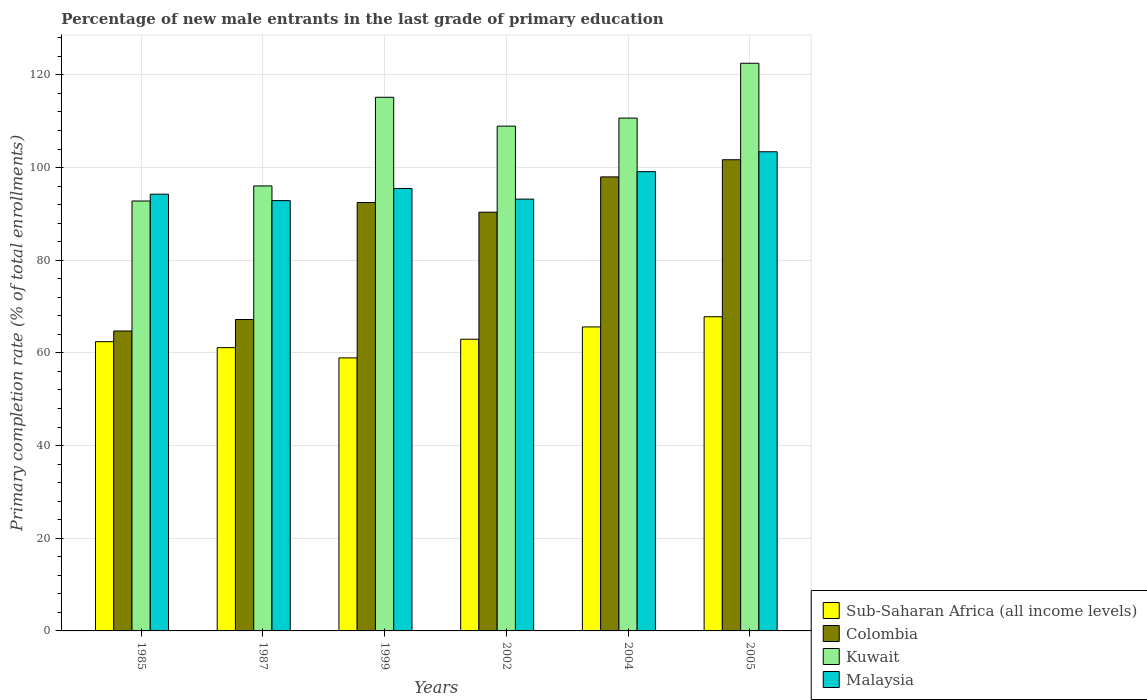Are the number of bars per tick equal to the number of legend labels?
Make the answer very short. Yes. How many bars are there on the 3rd tick from the left?
Give a very brief answer. 4. How many bars are there on the 1st tick from the right?
Keep it short and to the point. 4. What is the percentage of new male entrants in Malaysia in 1999?
Your answer should be very brief. 95.49. Across all years, what is the maximum percentage of new male entrants in Kuwait?
Offer a terse response. 122.51. Across all years, what is the minimum percentage of new male entrants in Colombia?
Make the answer very short. 64.73. In which year was the percentage of new male entrants in Sub-Saharan Africa (all income levels) maximum?
Your answer should be compact. 2005. In which year was the percentage of new male entrants in Colombia minimum?
Your answer should be very brief. 1985. What is the total percentage of new male entrants in Colombia in the graph?
Offer a terse response. 514.42. What is the difference between the percentage of new male entrants in Sub-Saharan Africa (all income levels) in 1985 and that in 2004?
Provide a succinct answer. -3.19. What is the difference between the percentage of new male entrants in Kuwait in 2002 and the percentage of new male entrants in Sub-Saharan Africa (all income levels) in 1985?
Offer a terse response. 46.52. What is the average percentage of new male entrants in Colombia per year?
Offer a terse response. 85.74. In the year 1999, what is the difference between the percentage of new male entrants in Colombia and percentage of new male entrants in Malaysia?
Provide a succinct answer. -3.03. What is the ratio of the percentage of new male entrants in Sub-Saharan Africa (all income levels) in 2002 to that in 2004?
Make the answer very short. 0.96. Is the percentage of new male entrants in Kuwait in 1987 less than that in 2002?
Keep it short and to the point. Yes. Is the difference between the percentage of new male entrants in Colombia in 1987 and 2002 greater than the difference between the percentage of new male entrants in Malaysia in 1987 and 2002?
Ensure brevity in your answer.  No. What is the difference between the highest and the second highest percentage of new male entrants in Kuwait?
Offer a terse response. 7.34. What is the difference between the highest and the lowest percentage of new male entrants in Malaysia?
Offer a terse response. 10.55. Is it the case that in every year, the sum of the percentage of new male entrants in Colombia and percentage of new male entrants in Malaysia is greater than the sum of percentage of new male entrants in Kuwait and percentage of new male entrants in Sub-Saharan Africa (all income levels)?
Keep it short and to the point. No. What does the 4th bar from the left in 2004 represents?
Provide a succinct answer. Malaysia. What does the 4th bar from the right in 2005 represents?
Your answer should be compact. Sub-Saharan Africa (all income levels). Are all the bars in the graph horizontal?
Ensure brevity in your answer.  No. How many years are there in the graph?
Your answer should be compact. 6. What is the difference between two consecutive major ticks on the Y-axis?
Make the answer very short. 20. Are the values on the major ticks of Y-axis written in scientific E-notation?
Your answer should be compact. No. Does the graph contain any zero values?
Provide a succinct answer. No. What is the title of the graph?
Your answer should be very brief. Percentage of new male entrants in the last grade of primary education. Does "San Marino" appear as one of the legend labels in the graph?
Offer a very short reply. No. What is the label or title of the X-axis?
Provide a short and direct response. Years. What is the label or title of the Y-axis?
Provide a short and direct response. Primary completion rate (% of total enrollments). What is the Primary completion rate (% of total enrollments) in Sub-Saharan Africa (all income levels) in 1985?
Provide a short and direct response. 62.42. What is the Primary completion rate (% of total enrollments) in Colombia in 1985?
Provide a succinct answer. 64.73. What is the Primary completion rate (% of total enrollments) in Kuwait in 1985?
Your response must be concise. 92.78. What is the Primary completion rate (% of total enrollments) of Malaysia in 1985?
Ensure brevity in your answer.  94.25. What is the Primary completion rate (% of total enrollments) of Sub-Saharan Africa (all income levels) in 1987?
Your response must be concise. 61.14. What is the Primary completion rate (% of total enrollments) in Colombia in 1987?
Your response must be concise. 67.21. What is the Primary completion rate (% of total enrollments) in Kuwait in 1987?
Make the answer very short. 96.04. What is the Primary completion rate (% of total enrollments) of Malaysia in 1987?
Keep it short and to the point. 92.86. What is the Primary completion rate (% of total enrollments) in Sub-Saharan Africa (all income levels) in 1999?
Your response must be concise. 58.92. What is the Primary completion rate (% of total enrollments) in Colombia in 1999?
Provide a short and direct response. 92.46. What is the Primary completion rate (% of total enrollments) of Kuwait in 1999?
Your answer should be very brief. 115.16. What is the Primary completion rate (% of total enrollments) in Malaysia in 1999?
Your answer should be compact. 95.49. What is the Primary completion rate (% of total enrollments) of Sub-Saharan Africa (all income levels) in 2002?
Give a very brief answer. 62.95. What is the Primary completion rate (% of total enrollments) of Colombia in 2002?
Offer a very short reply. 90.36. What is the Primary completion rate (% of total enrollments) in Kuwait in 2002?
Give a very brief answer. 108.94. What is the Primary completion rate (% of total enrollments) of Malaysia in 2002?
Your answer should be very brief. 93.19. What is the Primary completion rate (% of total enrollments) of Sub-Saharan Africa (all income levels) in 2004?
Your answer should be compact. 65.61. What is the Primary completion rate (% of total enrollments) of Colombia in 2004?
Provide a short and direct response. 97.98. What is the Primary completion rate (% of total enrollments) of Kuwait in 2004?
Ensure brevity in your answer.  110.67. What is the Primary completion rate (% of total enrollments) in Malaysia in 2004?
Your answer should be compact. 99.11. What is the Primary completion rate (% of total enrollments) in Sub-Saharan Africa (all income levels) in 2005?
Provide a short and direct response. 67.8. What is the Primary completion rate (% of total enrollments) of Colombia in 2005?
Give a very brief answer. 101.69. What is the Primary completion rate (% of total enrollments) of Kuwait in 2005?
Keep it short and to the point. 122.51. What is the Primary completion rate (% of total enrollments) in Malaysia in 2005?
Your answer should be very brief. 103.41. Across all years, what is the maximum Primary completion rate (% of total enrollments) in Sub-Saharan Africa (all income levels)?
Give a very brief answer. 67.8. Across all years, what is the maximum Primary completion rate (% of total enrollments) of Colombia?
Provide a succinct answer. 101.69. Across all years, what is the maximum Primary completion rate (% of total enrollments) in Kuwait?
Provide a short and direct response. 122.51. Across all years, what is the maximum Primary completion rate (% of total enrollments) of Malaysia?
Provide a succinct answer. 103.41. Across all years, what is the minimum Primary completion rate (% of total enrollments) of Sub-Saharan Africa (all income levels)?
Offer a very short reply. 58.92. Across all years, what is the minimum Primary completion rate (% of total enrollments) in Colombia?
Offer a very short reply. 64.73. Across all years, what is the minimum Primary completion rate (% of total enrollments) in Kuwait?
Your response must be concise. 92.78. Across all years, what is the minimum Primary completion rate (% of total enrollments) of Malaysia?
Provide a short and direct response. 92.86. What is the total Primary completion rate (% of total enrollments) of Sub-Saharan Africa (all income levels) in the graph?
Offer a very short reply. 378.83. What is the total Primary completion rate (% of total enrollments) in Colombia in the graph?
Make the answer very short. 514.42. What is the total Primary completion rate (% of total enrollments) of Kuwait in the graph?
Your answer should be compact. 646.1. What is the total Primary completion rate (% of total enrollments) of Malaysia in the graph?
Your response must be concise. 578.3. What is the difference between the Primary completion rate (% of total enrollments) of Sub-Saharan Africa (all income levels) in 1985 and that in 1987?
Make the answer very short. 1.28. What is the difference between the Primary completion rate (% of total enrollments) in Colombia in 1985 and that in 1987?
Your answer should be compact. -2.48. What is the difference between the Primary completion rate (% of total enrollments) of Kuwait in 1985 and that in 1987?
Your answer should be very brief. -3.26. What is the difference between the Primary completion rate (% of total enrollments) of Malaysia in 1985 and that in 1987?
Keep it short and to the point. 1.39. What is the difference between the Primary completion rate (% of total enrollments) in Sub-Saharan Africa (all income levels) in 1985 and that in 1999?
Offer a terse response. 3.5. What is the difference between the Primary completion rate (% of total enrollments) in Colombia in 1985 and that in 1999?
Provide a short and direct response. -27.73. What is the difference between the Primary completion rate (% of total enrollments) in Kuwait in 1985 and that in 1999?
Provide a short and direct response. -22.38. What is the difference between the Primary completion rate (% of total enrollments) of Malaysia in 1985 and that in 1999?
Ensure brevity in your answer.  -1.24. What is the difference between the Primary completion rate (% of total enrollments) of Sub-Saharan Africa (all income levels) in 1985 and that in 2002?
Offer a terse response. -0.53. What is the difference between the Primary completion rate (% of total enrollments) of Colombia in 1985 and that in 2002?
Your response must be concise. -25.63. What is the difference between the Primary completion rate (% of total enrollments) of Kuwait in 1985 and that in 2002?
Ensure brevity in your answer.  -16.16. What is the difference between the Primary completion rate (% of total enrollments) in Malaysia in 1985 and that in 2002?
Offer a very short reply. 1.06. What is the difference between the Primary completion rate (% of total enrollments) of Sub-Saharan Africa (all income levels) in 1985 and that in 2004?
Your response must be concise. -3.19. What is the difference between the Primary completion rate (% of total enrollments) in Colombia in 1985 and that in 2004?
Your response must be concise. -33.25. What is the difference between the Primary completion rate (% of total enrollments) of Kuwait in 1985 and that in 2004?
Provide a succinct answer. -17.89. What is the difference between the Primary completion rate (% of total enrollments) of Malaysia in 1985 and that in 2004?
Offer a terse response. -4.87. What is the difference between the Primary completion rate (% of total enrollments) in Sub-Saharan Africa (all income levels) in 1985 and that in 2005?
Your response must be concise. -5.38. What is the difference between the Primary completion rate (% of total enrollments) in Colombia in 1985 and that in 2005?
Offer a very short reply. -36.96. What is the difference between the Primary completion rate (% of total enrollments) of Kuwait in 1985 and that in 2005?
Give a very brief answer. -29.73. What is the difference between the Primary completion rate (% of total enrollments) of Malaysia in 1985 and that in 2005?
Give a very brief answer. -9.16. What is the difference between the Primary completion rate (% of total enrollments) in Sub-Saharan Africa (all income levels) in 1987 and that in 1999?
Your answer should be compact. 2.22. What is the difference between the Primary completion rate (% of total enrollments) in Colombia in 1987 and that in 1999?
Keep it short and to the point. -25.25. What is the difference between the Primary completion rate (% of total enrollments) in Kuwait in 1987 and that in 1999?
Ensure brevity in your answer.  -19.13. What is the difference between the Primary completion rate (% of total enrollments) of Malaysia in 1987 and that in 1999?
Your answer should be compact. -2.63. What is the difference between the Primary completion rate (% of total enrollments) of Sub-Saharan Africa (all income levels) in 1987 and that in 2002?
Your answer should be very brief. -1.82. What is the difference between the Primary completion rate (% of total enrollments) in Colombia in 1987 and that in 2002?
Offer a terse response. -23.15. What is the difference between the Primary completion rate (% of total enrollments) in Kuwait in 1987 and that in 2002?
Give a very brief answer. -12.9. What is the difference between the Primary completion rate (% of total enrollments) of Malaysia in 1987 and that in 2002?
Provide a succinct answer. -0.33. What is the difference between the Primary completion rate (% of total enrollments) of Sub-Saharan Africa (all income levels) in 1987 and that in 2004?
Ensure brevity in your answer.  -4.47. What is the difference between the Primary completion rate (% of total enrollments) of Colombia in 1987 and that in 2004?
Your answer should be compact. -30.78. What is the difference between the Primary completion rate (% of total enrollments) in Kuwait in 1987 and that in 2004?
Your response must be concise. -14.63. What is the difference between the Primary completion rate (% of total enrollments) in Malaysia in 1987 and that in 2004?
Your response must be concise. -6.25. What is the difference between the Primary completion rate (% of total enrollments) of Sub-Saharan Africa (all income levels) in 1987 and that in 2005?
Offer a very short reply. -6.67. What is the difference between the Primary completion rate (% of total enrollments) of Colombia in 1987 and that in 2005?
Ensure brevity in your answer.  -34.48. What is the difference between the Primary completion rate (% of total enrollments) in Kuwait in 1987 and that in 2005?
Keep it short and to the point. -26.47. What is the difference between the Primary completion rate (% of total enrollments) of Malaysia in 1987 and that in 2005?
Make the answer very short. -10.55. What is the difference between the Primary completion rate (% of total enrollments) of Sub-Saharan Africa (all income levels) in 1999 and that in 2002?
Your response must be concise. -4.03. What is the difference between the Primary completion rate (% of total enrollments) of Colombia in 1999 and that in 2002?
Ensure brevity in your answer.  2.1. What is the difference between the Primary completion rate (% of total enrollments) of Kuwait in 1999 and that in 2002?
Offer a terse response. 6.23. What is the difference between the Primary completion rate (% of total enrollments) of Malaysia in 1999 and that in 2002?
Give a very brief answer. 2.3. What is the difference between the Primary completion rate (% of total enrollments) in Sub-Saharan Africa (all income levels) in 1999 and that in 2004?
Provide a succinct answer. -6.69. What is the difference between the Primary completion rate (% of total enrollments) of Colombia in 1999 and that in 2004?
Your answer should be compact. -5.52. What is the difference between the Primary completion rate (% of total enrollments) of Kuwait in 1999 and that in 2004?
Offer a terse response. 4.49. What is the difference between the Primary completion rate (% of total enrollments) in Malaysia in 1999 and that in 2004?
Your answer should be compact. -3.62. What is the difference between the Primary completion rate (% of total enrollments) in Sub-Saharan Africa (all income levels) in 1999 and that in 2005?
Ensure brevity in your answer.  -8.88. What is the difference between the Primary completion rate (% of total enrollments) in Colombia in 1999 and that in 2005?
Ensure brevity in your answer.  -9.23. What is the difference between the Primary completion rate (% of total enrollments) in Kuwait in 1999 and that in 2005?
Keep it short and to the point. -7.34. What is the difference between the Primary completion rate (% of total enrollments) of Malaysia in 1999 and that in 2005?
Provide a succinct answer. -7.92. What is the difference between the Primary completion rate (% of total enrollments) of Sub-Saharan Africa (all income levels) in 2002 and that in 2004?
Provide a short and direct response. -2.65. What is the difference between the Primary completion rate (% of total enrollments) of Colombia in 2002 and that in 2004?
Give a very brief answer. -7.62. What is the difference between the Primary completion rate (% of total enrollments) in Kuwait in 2002 and that in 2004?
Ensure brevity in your answer.  -1.73. What is the difference between the Primary completion rate (% of total enrollments) in Malaysia in 2002 and that in 2004?
Give a very brief answer. -5.92. What is the difference between the Primary completion rate (% of total enrollments) of Sub-Saharan Africa (all income levels) in 2002 and that in 2005?
Your answer should be compact. -4.85. What is the difference between the Primary completion rate (% of total enrollments) of Colombia in 2002 and that in 2005?
Your answer should be very brief. -11.32. What is the difference between the Primary completion rate (% of total enrollments) of Kuwait in 2002 and that in 2005?
Provide a short and direct response. -13.57. What is the difference between the Primary completion rate (% of total enrollments) in Malaysia in 2002 and that in 2005?
Your response must be concise. -10.22. What is the difference between the Primary completion rate (% of total enrollments) of Sub-Saharan Africa (all income levels) in 2004 and that in 2005?
Your answer should be compact. -2.2. What is the difference between the Primary completion rate (% of total enrollments) in Colombia in 2004 and that in 2005?
Ensure brevity in your answer.  -3.7. What is the difference between the Primary completion rate (% of total enrollments) in Kuwait in 2004 and that in 2005?
Keep it short and to the point. -11.84. What is the difference between the Primary completion rate (% of total enrollments) of Malaysia in 2004 and that in 2005?
Ensure brevity in your answer.  -4.3. What is the difference between the Primary completion rate (% of total enrollments) of Sub-Saharan Africa (all income levels) in 1985 and the Primary completion rate (% of total enrollments) of Colombia in 1987?
Give a very brief answer. -4.79. What is the difference between the Primary completion rate (% of total enrollments) in Sub-Saharan Africa (all income levels) in 1985 and the Primary completion rate (% of total enrollments) in Kuwait in 1987?
Provide a short and direct response. -33.62. What is the difference between the Primary completion rate (% of total enrollments) of Sub-Saharan Africa (all income levels) in 1985 and the Primary completion rate (% of total enrollments) of Malaysia in 1987?
Your response must be concise. -30.44. What is the difference between the Primary completion rate (% of total enrollments) of Colombia in 1985 and the Primary completion rate (% of total enrollments) of Kuwait in 1987?
Your answer should be compact. -31.31. What is the difference between the Primary completion rate (% of total enrollments) in Colombia in 1985 and the Primary completion rate (% of total enrollments) in Malaysia in 1987?
Your response must be concise. -28.13. What is the difference between the Primary completion rate (% of total enrollments) of Kuwait in 1985 and the Primary completion rate (% of total enrollments) of Malaysia in 1987?
Your answer should be very brief. -0.08. What is the difference between the Primary completion rate (% of total enrollments) of Sub-Saharan Africa (all income levels) in 1985 and the Primary completion rate (% of total enrollments) of Colombia in 1999?
Keep it short and to the point. -30.04. What is the difference between the Primary completion rate (% of total enrollments) of Sub-Saharan Africa (all income levels) in 1985 and the Primary completion rate (% of total enrollments) of Kuwait in 1999?
Your response must be concise. -52.74. What is the difference between the Primary completion rate (% of total enrollments) of Sub-Saharan Africa (all income levels) in 1985 and the Primary completion rate (% of total enrollments) of Malaysia in 1999?
Provide a succinct answer. -33.07. What is the difference between the Primary completion rate (% of total enrollments) of Colombia in 1985 and the Primary completion rate (% of total enrollments) of Kuwait in 1999?
Your answer should be compact. -50.44. What is the difference between the Primary completion rate (% of total enrollments) of Colombia in 1985 and the Primary completion rate (% of total enrollments) of Malaysia in 1999?
Keep it short and to the point. -30.76. What is the difference between the Primary completion rate (% of total enrollments) in Kuwait in 1985 and the Primary completion rate (% of total enrollments) in Malaysia in 1999?
Make the answer very short. -2.71. What is the difference between the Primary completion rate (% of total enrollments) of Sub-Saharan Africa (all income levels) in 1985 and the Primary completion rate (% of total enrollments) of Colombia in 2002?
Offer a very short reply. -27.94. What is the difference between the Primary completion rate (% of total enrollments) in Sub-Saharan Africa (all income levels) in 1985 and the Primary completion rate (% of total enrollments) in Kuwait in 2002?
Your answer should be compact. -46.52. What is the difference between the Primary completion rate (% of total enrollments) of Sub-Saharan Africa (all income levels) in 1985 and the Primary completion rate (% of total enrollments) of Malaysia in 2002?
Provide a short and direct response. -30.77. What is the difference between the Primary completion rate (% of total enrollments) of Colombia in 1985 and the Primary completion rate (% of total enrollments) of Kuwait in 2002?
Keep it short and to the point. -44.21. What is the difference between the Primary completion rate (% of total enrollments) in Colombia in 1985 and the Primary completion rate (% of total enrollments) in Malaysia in 2002?
Your response must be concise. -28.46. What is the difference between the Primary completion rate (% of total enrollments) of Kuwait in 1985 and the Primary completion rate (% of total enrollments) of Malaysia in 2002?
Provide a succinct answer. -0.41. What is the difference between the Primary completion rate (% of total enrollments) of Sub-Saharan Africa (all income levels) in 1985 and the Primary completion rate (% of total enrollments) of Colombia in 2004?
Offer a terse response. -35.56. What is the difference between the Primary completion rate (% of total enrollments) in Sub-Saharan Africa (all income levels) in 1985 and the Primary completion rate (% of total enrollments) in Kuwait in 2004?
Make the answer very short. -48.25. What is the difference between the Primary completion rate (% of total enrollments) in Sub-Saharan Africa (all income levels) in 1985 and the Primary completion rate (% of total enrollments) in Malaysia in 2004?
Make the answer very short. -36.69. What is the difference between the Primary completion rate (% of total enrollments) of Colombia in 1985 and the Primary completion rate (% of total enrollments) of Kuwait in 2004?
Ensure brevity in your answer.  -45.94. What is the difference between the Primary completion rate (% of total enrollments) of Colombia in 1985 and the Primary completion rate (% of total enrollments) of Malaysia in 2004?
Offer a very short reply. -34.38. What is the difference between the Primary completion rate (% of total enrollments) of Kuwait in 1985 and the Primary completion rate (% of total enrollments) of Malaysia in 2004?
Keep it short and to the point. -6.33. What is the difference between the Primary completion rate (% of total enrollments) of Sub-Saharan Africa (all income levels) in 1985 and the Primary completion rate (% of total enrollments) of Colombia in 2005?
Give a very brief answer. -39.27. What is the difference between the Primary completion rate (% of total enrollments) in Sub-Saharan Africa (all income levels) in 1985 and the Primary completion rate (% of total enrollments) in Kuwait in 2005?
Make the answer very short. -60.09. What is the difference between the Primary completion rate (% of total enrollments) in Sub-Saharan Africa (all income levels) in 1985 and the Primary completion rate (% of total enrollments) in Malaysia in 2005?
Offer a terse response. -40.99. What is the difference between the Primary completion rate (% of total enrollments) of Colombia in 1985 and the Primary completion rate (% of total enrollments) of Kuwait in 2005?
Ensure brevity in your answer.  -57.78. What is the difference between the Primary completion rate (% of total enrollments) of Colombia in 1985 and the Primary completion rate (% of total enrollments) of Malaysia in 2005?
Make the answer very short. -38.68. What is the difference between the Primary completion rate (% of total enrollments) in Kuwait in 1985 and the Primary completion rate (% of total enrollments) in Malaysia in 2005?
Give a very brief answer. -10.63. What is the difference between the Primary completion rate (% of total enrollments) of Sub-Saharan Africa (all income levels) in 1987 and the Primary completion rate (% of total enrollments) of Colombia in 1999?
Your response must be concise. -31.32. What is the difference between the Primary completion rate (% of total enrollments) of Sub-Saharan Africa (all income levels) in 1987 and the Primary completion rate (% of total enrollments) of Kuwait in 1999?
Give a very brief answer. -54.03. What is the difference between the Primary completion rate (% of total enrollments) of Sub-Saharan Africa (all income levels) in 1987 and the Primary completion rate (% of total enrollments) of Malaysia in 1999?
Your response must be concise. -34.35. What is the difference between the Primary completion rate (% of total enrollments) of Colombia in 1987 and the Primary completion rate (% of total enrollments) of Kuwait in 1999?
Ensure brevity in your answer.  -47.96. What is the difference between the Primary completion rate (% of total enrollments) in Colombia in 1987 and the Primary completion rate (% of total enrollments) in Malaysia in 1999?
Offer a very short reply. -28.28. What is the difference between the Primary completion rate (% of total enrollments) in Kuwait in 1987 and the Primary completion rate (% of total enrollments) in Malaysia in 1999?
Your answer should be very brief. 0.55. What is the difference between the Primary completion rate (% of total enrollments) of Sub-Saharan Africa (all income levels) in 1987 and the Primary completion rate (% of total enrollments) of Colombia in 2002?
Ensure brevity in your answer.  -29.22. What is the difference between the Primary completion rate (% of total enrollments) of Sub-Saharan Africa (all income levels) in 1987 and the Primary completion rate (% of total enrollments) of Kuwait in 2002?
Offer a terse response. -47.8. What is the difference between the Primary completion rate (% of total enrollments) in Sub-Saharan Africa (all income levels) in 1987 and the Primary completion rate (% of total enrollments) in Malaysia in 2002?
Provide a succinct answer. -32.05. What is the difference between the Primary completion rate (% of total enrollments) in Colombia in 1987 and the Primary completion rate (% of total enrollments) in Kuwait in 2002?
Provide a short and direct response. -41.73. What is the difference between the Primary completion rate (% of total enrollments) of Colombia in 1987 and the Primary completion rate (% of total enrollments) of Malaysia in 2002?
Keep it short and to the point. -25.98. What is the difference between the Primary completion rate (% of total enrollments) of Kuwait in 1987 and the Primary completion rate (% of total enrollments) of Malaysia in 2002?
Offer a very short reply. 2.85. What is the difference between the Primary completion rate (% of total enrollments) in Sub-Saharan Africa (all income levels) in 1987 and the Primary completion rate (% of total enrollments) in Colombia in 2004?
Provide a short and direct response. -36.85. What is the difference between the Primary completion rate (% of total enrollments) in Sub-Saharan Africa (all income levels) in 1987 and the Primary completion rate (% of total enrollments) in Kuwait in 2004?
Provide a succinct answer. -49.53. What is the difference between the Primary completion rate (% of total enrollments) of Sub-Saharan Africa (all income levels) in 1987 and the Primary completion rate (% of total enrollments) of Malaysia in 2004?
Offer a terse response. -37.98. What is the difference between the Primary completion rate (% of total enrollments) of Colombia in 1987 and the Primary completion rate (% of total enrollments) of Kuwait in 2004?
Your response must be concise. -43.46. What is the difference between the Primary completion rate (% of total enrollments) in Colombia in 1987 and the Primary completion rate (% of total enrollments) in Malaysia in 2004?
Offer a very short reply. -31.91. What is the difference between the Primary completion rate (% of total enrollments) of Kuwait in 1987 and the Primary completion rate (% of total enrollments) of Malaysia in 2004?
Offer a very short reply. -3.08. What is the difference between the Primary completion rate (% of total enrollments) of Sub-Saharan Africa (all income levels) in 1987 and the Primary completion rate (% of total enrollments) of Colombia in 2005?
Your answer should be very brief. -40.55. What is the difference between the Primary completion rate (% of total enrollments) in Sub-Saharan Africa (all income levels) in 1987 and the Primary completion rate (% of total enrollments) in Kuwait in 2005?
Offer a very short reply. -61.37. What is the difference between the Primary completion rate (% of total enrollments) in Sub-Saharan Africa (all income levels) in 1987 and the Primary completion rate (% of total enrollments) in Malaysia in 2005?
Provide a short and direct response. -42.27. What is the difference between the Primary completion rate (% of total enrollments) of Colombia in 1987 and the Primary completion rate (% of total enrollments) of Kuwait in 2005?
Your answer should be very brief. -55.3. What is the difference between the Primary completion rate (% of total enrollments) of Colombia in 1987 and the Primary completion rate (% of total enrollments) of Malaysia in 2005?
Offer a terse response. -36.2. What is the difference between the Primary completion rate (% of total enrollments) in Kuwait in 1987 and the Primary completion rate (% of total enrollments) in Malaysia in 2005?
Offer a terse response. -7.37. What is the difference between the Primary completion rate (% of total enrollments) in Sub-Saharan Africa (all income levels) in 1999 and the Primary completion rate (% of total enrollments) in Colombia in 2002?
Keep it short and to the point. -31.44. What is the difference between the Primary completion rate (% of total enrollments) in Sub-Saharan Africa (all income levels) in 1999 and the Primary completion rate (% of total enrollments) in Kuwait in 2002?
Offer a very short reply. -50.02. What is the difference between the Primary completion rate (% of total enrollments) in Sub-Saharan Africa (all income levels) in 1999 and the Primary completion rate (% of total enrollments) in Malaysia in 2002?
Give a very brief answer. -34.27. What is the difference between the Primary completion rate (% of total enrollments) of Colombia in 1999 and the Primary completion rate (% of total enrollments) of Kuwait in 2002?
Keep it short and to the point. -16.48. What is the difference between the Primary completion rate (% of total enrollments) in Colombia in 1999 and the Primary completion rate (% of total enrollments) in Malaysia in 2002?
Your response must be concise. -0.73. What is the difference between the Primary completion rate (% of total enrollments) of Kuwait in 1999 and the Primary completion rate (% of total enrollments) of Malaysia in 2002?
Offer a terse response. 21.98. What is the difference between the Primary completion rate (% of total enrollments) of Sub-Saharan Africa (all income levels) in 1999 and the Primary completion rate (% of total enrollments) of Colombia in 2004?
Your answer should be very brief. -39.06. What is the difference between the Primary completion rate (% of total enrollments) of Sub-Saharan Africa (all income levels) in 1999 and the Primary completion rate (% of total enrollments) of Kuwait in 2004?
Your answer should be compact. -51.75. What is the difference between the Primary completion rate (% of total enrollments) of Sub-Saharan Africa (all income levels) in 1999 and the Primary completion rate (% of total enrollments) of Malaysia in 2004?
Give a very brief answer. -40.19. What is the difference between the Primary completion rate (% of total enrollments) in Colombia in 1999 and the Primary completion rate (% of total enrollments) in Kuwait in 2004?
Keep it short and to the point. -18.21. What is the difference between the Primary completion rate (% of total enrollments) in Colombia in 1999 and the Primary completion rate (% of total enrollments) in Malaysia in 2004?
Give a very brief answer. -6.65. What is the difference between the Primary completion rate (% of total enrollments) in Kuwait in 1999 and the Primary completion rate (% of total enrollments) in Malaysia in 2004?
Provide a succinct answer. 16.05. What is the difference between the Primary completion rate (% of total enrollments) in Sub-Saharan Africa (all income levels) in 1999 and the Primary completion rate (% of total enrollments) in Colombia in 2005?
Your response must be concise. -42.77. What is the difference between the Primary completion rate (% of total enrollments) of Sub-Saharan Africa (all income levels) in 1999 and the Primary completion rate (% of total enrollments) of Kuwait in 2005?
Keep it short and to the point. -63.59. What is the difference between the Primary completion rate (% of total enrollments) in Sub-Saharan Africa (all income levels) in 1999 and the Primary completion rate (% of total enrollments) in Malaysia in 2005?
Your response must be concise. -44.49. What is the difference between the Primary completion rate (% of total enrollments) in Colombia in 1999 and the Primary completion rate (% of total enrollments) in Kuwait in 2005?
Give a very brief answer. -30.05. What is the difference between the Primary completion rate (% of total enrollments) of Colombia in 1999 and the Primary completion rate (% of total enrollments) of Malaysia in 2005?
Your answer should be compact. -10.95. What is the difference between the Primary completion rate (% of total enrollments) in Kuwait in 1999 and the Primary completion rate (% of total enrollments) in Malaysia in 2005?
Your response must be concise. 11.76. What is the difference between the Primary completion rate (% of total enrollments) of Sub-Saharan Africa (all income levels) in 2002 and the Primary completion rate (% of total enrollments) of Colombia in 2004?
Your answer should be compact. -35.03. What is the difference between the Primary completion rate (% of total enrollments) of Sub-Saharan Africa (all income levels) in 2002 and the Primary completion rate (% of total enrollments) of Kuwait in 2004?
Your answer should be very brief. -47.72. What is the difference between the Primary completion rate (% of total enrollments) of Sub-Saharan Africa (all income levels) in 2002 and the Primary completion rate (% of total enrollments) of Malaysia in 2004?
Make the answer very short. -36.16. What is the difference between the Primary completion rate (% of total enrollments) in Colombia in 2002 and the Primary completion rate (% of total enrollments) in Kuwait in 2004?
Offer a very short reply. -20.31. What is the difference between the Primary completion rate (% of total enrollments) in Colombia in 2002 and the Primary completion rate (% of total enrollments) in Malaysia in 2004?
Ensure brevity in your answer.  -8.75. What is the difference between the Primary completion rate (% of total enrollments) in Kuwait in 2002 and the Primary completion rate (% of total enrollments) in Malaysia in 2004?
Your response must be concise. 9.83. What is the difference between the Primary completion rate (% of total enrollments) of Sub-Saharan Africa (all income levels) in 2002 and the Primary completion rate (% of total enrollments) of Colombia in 2005?
Keep it short and to the point. -38.73. What is the difference between the Primary completion rate (% of total enrollments) in Sub-Saharan Africa (all income levels) in 2002 and the Primary completion rate (% of total enrollments) in Kuwait in 2005?
Your answer should be very brief. -59.56. What is the difference between the Primary completion rate (% of total enrollments) of Sub-Saharan Africa (all income levels) in 2002 and the Primary completion rate (% of total enrollments) of Malaysia in 2005?
Offer a terse response. -40.46. What is the difference between the Primary completion rate (% of total enrollments) of Colombia in 2002 and the Primary completion rate (% of total enrollments) of Kuwait in 2005?
Your answer should be compact. -32.15. What is the difference between the Primary completion rate (% of total enrollments) in Colombia in 2002 and the Primary completion rate (% of total enrollments) in Malaysia in 2005?
Your answer should be compact. -13.05. What is the difference between the Primary completion rate (% of total enrollments) of Kuwait in 2002 and the Primary completion rate (% of total enrollments) of Malaysia in 2005?
Keep it short and to the point. 5.53. What is the difference between the Primary completion rate (% of total enrollments) in Sub-Saharan Africa (all income levels) in 2004 and the Primary completion rate (% of total enrollments) in Colombia in 2005?
Your answer should be very brief. -36.08. What is the difference between the Primary completion rate (% of total enrollments) of Sub-Saharan Africa (all income levels) in 2004 and the Primary completion rate (% of total enrollments) of Kuwait in 2005?
Provide a short and direct response. -56.9. What is the difference between the Primary completion rate (% of total enrollments) in Sub-Saharan Africa (all income levels) in 2004 and the Primary completion rate (% of total enrollments) in Malaysia in 2005?
Provide a short and direct response. -37.8. What is the difference between the Primary completion rate (% of total enrollments) in Colombia in 2004 and the Primary completion rate (% of total enrollments) in Kuwait in 2005?
Keep it short and to the point. -24.52. What is the difference between the Primary completion rate (% of total enrollments) of Colombia in 2004 and the Primary completion rate (% of total enrollments) of Malaysia in 2005?
Your answer should be compact. -5.43. What is the difference between the Primary completion rate (% of total enrollments) of Kuwait in 2004 and the Primary completion rate (% of total enrollments) of Malaysia in 2005?
Your answer should be very brief. 7.26. What is the average Primary completion rate (% of total enrollments) of Sub-Saharan Africa (all income levels) per year?
Keep it short and to the point. 63.14. What is the average Primary completion rate (% of total enrollments) in Colombia per year?
Your answer should be very brief. 85.74. What is the average Primary completion rate (% of total enrollments) of Kuwait per year?
Keep it short and to the point. 107.68. What is the average Primary completion rate (% of total enrollments) in Malaysia per year?
Provide a short and direct response. 96.38. In the year 1985, what is the difference between the Primary completion rate (% of total enrollments) of Sub-Saharan Africa (all income levels) and Primary completion rate (% of total enrollments) of Colombia?
Give a very brief answer. -2.31. In the year 1985, what is the difference between the Primary completion rate (% of total enrollments) in Sub-Saharan Africa (all income levels) and Primary completion rate (% of total enrollments) in Kuwait?
Offer a terse response. -30.36. In the year 1985, what is the difference between the Primary completion rate (% of total enrollments) in Sub-Saharan Africa (all income levels) and Primary completion rate (% of total enrollments) in Malaysia?
Make the answer very short. -31.83. In the year 1985, what is the difference between the Primary completion rate (% of total enrollments) in Colombia and Primary completion rate (% of total enrollments) in Kuwait?
Ensure brevity in your answer.  -28.05. In the year 1985, what is the difference between the Primary completion rate (% of total enrollments) in Colombia and Primary completion rate (% of total enrollments) in Malaysia?
Your answer should be very brief. -29.52. In the year 1985, what is the difference between the Primary completion rate (% of total enrollments) in Kuwait and Primary completion rate (% of total enrollments) in Malaysia?
Your answer should be very brief. -1.47. In the year 1987, what is the difference between the Primary completion rate (% of total enrollments) in Sub-Saharan Africa (all income levels) and Primary completion rate (% of total enrollments) in Colombia?
Provide a short and direct response. -6.07. In the year 1987, what is the difference between the Primary completion rate (% of total enrollments) of Sub-Saharan Africa (all income levels) and Primary completion rate (% of total enrollments) of Kuwait?
Give a very brief answer. -34.9. In the year 1987, what is the difference between the Primary completion rate (% of total enrollments) in Sub-Saharan Africa (all income levels) and Primary completion rate (% of total enrollments) in Malaysia?
Provide a short and direct response. -31.72. In the year 1987, what is the difference between the Primary completion rate (% of total enrollments) in Colombia and Primary completion rate (% of total enrollments) in Kuwait?
Provide a succinct answer. -28.83. In the year 1987, what is the difference between the Primary completion rate (% of total enrollments) in Colombia and Primary completion rate (% of total enrollments) in Malaysia?
Provide a succinct answer. -25.65. In the year 1987, what is the difference between the Primary completion rate (% of total enrollments) of Kuwait and Primary completion rate (% of total enrollments) of Malaysia?
Keep it short and to the point. 3.18. In the year 1999, what is the difference between the Primary completion rate (% of total enrollments) in Sub-Saharan Africa (all income levels) and Primary completion rate (% of total enrollments) in Colombia?
Provide a short and direct response. -33.54. In the year 1999, what is the difference between the Primary completion rate (% of total enrollments) of Sub-Saharan Africa (all income levels) and Primary completion rate (% of total enrollments) of Kuwait?
Offer a terse response. -56.25. In the year 1999, what is the difference between the Primary completion rate (% of total enrollments) in Sub-Saharan Africa (all income levels) and Primary completion rate (% of total enrollments) in Malaysia?
Offer a terse response. -36.57. In the year 1999, what is the difference between the Primary completion rate (% of total enrollments) in Colombia and Primary completion rate (% of total enrollments) in Kuwait?
Keep it short and to the point. -22.71. In the year 1999, what is the difference between the Primary completion rate (% of total enrollments) in Colombia and Primary completion rate (% of total enrollments) in Malaysia?
Offer a terse response. -3.03. In the year 1999, what is the difference between the Primary completion rate (% of total enrollments) of Kuwait and Primary completion rate (% of total enrollments) of Malaysia?
Your answer should be compact. 19.68. In the year 2002, what is the difference between the Primary completion rate (% of total enrollments) in Sub-Saharan Africa (all income levels) and Primary completion rate (% of total enrollments) in Colombia?
Your answer should be very brief. -27.41. In the year 2002, what is the difference between the Primary completion rate (% of total enrollments) in Sub-Saharan Africa (all income levels) and Primary completion rate (% of total enrollments) in Kuwait?
Keep it short and to the point. -45.99. In the year 2002, what is the difference between the Primary completion rate (% of total enrollments) of Sub-Saharan Africa (all income levels) and Primary completion rate (% of total enrollments) of Malaysia?
Give a very brief answer. -30.24. In the year 2002, what is the difference between the Primary completion rate (% of total enrollments) of Colombia and Primary completion rate (% of total enrollments) of Kuwait?
Give a very brief answer. -18.58. In the year 2002, what is the difference between the Primary completion rate (% of total enrollments) of Colombia and Primary completion rate (% of total enrollments) of Malaysia?
Provide a succinct answer. -2.83. In the year 2002, what is the difference between the Primary completion rate (% of total enrollments) in Kuwait and Primary completion rate (% of total enrollments) in Malaysia?
Ensure brevity in your answer.  15.75. In the year 2004, what is the difference between the Primary completion rate (% of total enrollments) of Sub-Saharan Africa (all income levels) and Primary completion rate (% of total enrollments) of Colombia?
Your answer should be very brief. -32.38. In the year 2004, what is the difference between the Primary completion rate (% of total enrollments) of Sub-Saharan Africa (all income levels) and Primary completion rate (% of total enrollments) of Kuwait?
Provide a succinct answer. -45.06. In the year 2004, what is the difference between the Primary completion rate (% of total enrollments) in Sub-Saharan Africa (all income levels) and Primary completion rate (% of total enrollments) in Malaysia?
Offer a terse response. -33.51. In the year 2004, what is the difference between the Primary completion rate (% of total enrollments) in Colombia and Primary completion rate (% of total enrollments) in Kuwait?
Make the answer very short. -12.69. In the year 2004, what is the difference between the Primary completion rate (% of total enrollments) of Colombia and Primary completion rate (% of total enrollments) of Malaysia?
Ensure brevity in your answer.  -1.13. In the year 2004, what is the difference between the Primary completion rate (% of total enrollments) of Kuwait and Primary completion rate (% of total enrollments) of Malaysia?
Keep it short and to the point. 11.56. In the year 2005, what is the difference between the Primary completion rate (% of total enrollments) of Sub-Saharan Africa (all income levels) and Primary completion rate (% of total enrollments) of Colombia?
Offer a terse response. -33.88. In the year 2005, what is the difference between the Primary completion rate (% of total enrollments) of Sub-Saharan Africa (all income levels) and Primary completion rate (% of total enrollments) of Kuwait?
Provide a short and direct response. -54.7. In the year 2005, what is the difference between the Primary completion rate (% of total enrollments) of Sub-Saharan Africa (all income levels) and Primary completion rate (% of total enrollments) of Malaysia?
Your response must be concise. -35.61. In the year 2005, what is the difference between the Primary completion rate (% of total enrollments) in Colombia and Primary completion rate (% of total enrollments) in Kuwait?
Ensure brevity in your answer.  -20.82. In the year 2005, what is the difference between the Primary completion rate (% of total enrollments) of Colombia and Primary completion rate (% of total enrollments) of Malaysia?
Your response must be concise. -1.72. In the year 2005, what is the difference between the Primary completion rate (% of total enrollments) of Kuwait and Primary completion rate (% of total enrollments) of Malaysia?
Make the answer very short. 19.1. What is the ratio of the Primary completion rate (% of total enrollments) in Sub-Saharan Africa (all income levels) in 1985 to that in 1987?
Provide a succinct answer. 1.02. What is the ratio of the Primary completion rate (% of total enrollments) in Colombia in 1985 to that in 1987?
Offer a terse response. 0.96. What is the ratio of the Primary completion rate (% of total enrollments) of Kuwait in 1985 to that in 1987?
Your answer should be very brief. 0.97. What is the ratio of the Primary completion rate (% of total enrollments) of Malaysia in 1985 to that in 1987?
Keep it short and to the point. 1.01. What is the ratio of the Primary completion rate (% of total enrollments) in Sub-Saharan Africa (all income levels) in 1985 to that in 1999?
Make the answer very short. 1.06. What is the ratio of the Primary completion rate (% of total enrollments) of Colombia in 1985 to that in 1999?
Provide a short and direct response. 0.7. What is the ratio of the Primary completion rate (% of total enrollments) in Kuwait in 1985 to that in 1999?
Offer a very short reply. 0.81. What is the ratio of the Primary completion rate (% of total enrollments) of Malaysia in 1985 to that in 1999?
Offer a terse response. 0.99. What is the ratio of the Primary completion rate (% of total enrollments) of Colombia in 1985 to that in 2002?
Your response must be concise. 0.72. What is the ratio of the Primary completion rate (% of total enrollments) of Kuwait in 1985 to that in 2002?
Keep it short and to the point. 0.85. What is the ratio of the Primary completion rate (% of total enrollments) in Malaysia in 1985 to that in 2002?
Offer a terse response. 1.01. What is the ratio of the Primary completion rate (% of total enrollments) of Sub-Saharan Africa (all income levels) in 1985 to that in 2004?
Ensure brevity in your answer.  0.95. What is the ratio of the Primary completion rate (% of total enrollments) of Colombia in 1985 to that in 2004?
Make the answer very short. 0.66. What is the ratio of the Primary completion rate (% of total enrollments) of Kuwait in 1985 to that in 2004?
Your answer should be compact. 0.84. What is the ratio of the Primary completion rate (% of total enrollments) in Malaysia in 1985 to that in 2004?
Your answer should be compact. 0.95. What is the ratio of the Primary completion rate (% of total enrollments) in Sub-Saharan Africa (all income levels) in 1985 to that in 2005?
Ensure brevity in your answer.  0.92. What is the ratio of the Primary completion rate (% of total enrollments) in Colombia in 1985 to that in 2005?
Offer a terse response. 0.64. What is the ratio of the Primary completion rate (% of total enrollments) in Kuwait in 1985 to that in 2005?
Your answer should be very brief. 0.76. What is the ratio of the Primary completion rate (% of total enrollments) in Malaysia in 1985 to that in 2005?
Offer a very short reply. 0.91. What is the ratio of the Primary completion rate (% of total enrollments) in Sub-Saharan Africa (all income levels) in 1987 to that in 1999?
Offer a terse response. 1.04. What is the ratio of the Primary completion rate (% of total enrollments) in Colombia in 1987 to that in 1999?
Provide a short and direct response. 0.73. What is the ratio of the Primary completion rate (% of total enrollments) in Kuwait in 1987 to that in 1999?
Offer a terse response. 0.83. What is the ratio of the Primary completion rate (% of total enrollments) in Malaysia in 1987 to that in 1999?
Offer a very short reply. 0.97. What is the ratio of the Primary completion rate (% of total enrollments) in Sub-Saharan Africa (all income levels) in 1987 to that in 2002?
Offer a terse response. 0.97. What is the ratio of the Primary completion rate (% of total enrollments) of Colombia in 1987 to that in 2002?
Keep it short and to the point. 0.74. What is the ratio of the Primary completion rate (% of total enrollments) of Kuwait in 1987 to that in 2002?
Your answer should be compact. 0.88. What is the ratio of the Primary completion rate (% of total enrollments) in Malaysia in 1987 to that in 2002?
Provide a short and direct response. 1. What is the ratio of the Primary completion rate (% of total enrollments) in Sub-Saharan Africa (all income levels) in 1987 to that in 2004?
Your answer should be very brief. 0.93. What is the ratio of the Primary completion rate (% of total enrollments) of Colombia in 1987 to that in 2004?
Give a very brief answer. 0.69. What is the ratio of the Primary completion rate (% of total enrollments) in Kuwait in 1987 to that in 2004?
Provide a short and direct response. 0.87. What is the ratio of the Primary completion rate (% of total enrollments) of Malaysia in 1987 to that in 2004?
Give a very brief answer. 0.94. What is the ratio of the Primary completion rate (% of total enrollments) of Sub-Saharan Africa (all income levels) in 1987 to that in 2005?
Provide a short and direct response. 0.9. What is the ratio of the Primary completion rate (% of total enrollments) in Colombia in 1987 to that in 2005?
Offer a terse response. 0.66. What is the ratio of the Primary completion rate (% of total enrollments) of Kuwait in 1987 to that in 2005?
Your response must be concise. 0.78. What is the ratio of the Primary completion rate (% of total enrollments) of Malaysia in 1987 to that in 2005?
Keep it short and to the point. 0.9. What is the ratio of the Primary completion rate (% of total enrollments) in Sub-Saharan Africa (all income levels) in 1999 to that in 2002?
Provide a short and direct response. 0.94. What is the ratio of the Primary completion rate (% of total enrollments) of Colombia in 1999 to that in 2002?
Your answer should be compact. 1.02. What is the ratio of the Primary completion rate (% of total enrollments) of Kuwait in 1999 to that in 2002?
Provide a short and direct response. 1.06. What is the ratio of the Primary completion rate (% of total enrollments) of Malaysia in 1999 to that in 2002?
Keep it short and to the point. 1.02. What is the ratio of the Primary completion rate (% of total enrollments) of Sub-Saharan Africa (all income levels) in 1999 to that in 2004?
Provide a succinct answer. 0.9. What is the ratio of the Primary completion rate (% of total enrollments) of Colombia in 1999 to that in 2004?
Your answer should be very brief. 0.94. What is the ratio of the Primary completion rate (% of total enrollments) in Kuwait in 1999 to that in 2004?
Give a very brief answer. 1.04. What is the ratio of the Primary completion rate (% of total enrollments) of Malaysia in 1999 to that in 2004?
Offer a very short reply. 0.96. What is the ratio of the Primary completion rate (% of total enrollments) of Sub-Saharan Africa (all income levels) in 1999 to that in 2005?
Keep it short and to the point. 0.87. What is the ratio of the Primary completion rate (% of total enrollments) of Colombia in 1999 to that in 2005?
Ensure brevity in your answer.  0.91. What is the ratio of the Primary completion rate (% of total enrollments) in Kuwait in 1999 to that in 2005?
Keep it short and to the point. 0.94. What is the ratio of the Primary completion rate (% of total enrollments) of Malaysia in 1999 to that in 2005?
Offer a terse response. 0.92. What is the ratio of the Primary completion rate (% of total enrollments) of Sub-Saharan Africa (all income levels) in 2002 to that in 2004?
Provide a succinct answer. 0.96. What is the ratio of the Primary completion rate (% of total enrollments) of Colombia in 2002 to that in 2004?
Provide a succinct answer. 0.92. What is the ratio of the Primary completion rate (% of total enrollments) in Kuwait in 2002 to that in 2004?
Provide a succinct answer. 0.98. What is the ratio of the Primary completion rate (% of total enrollments) of Malaysia in 2002 to that in 2004?
Provide a short and direct response. 0.94. What is the ratio of the Primary completion rate (% of total enrollments) in Sub-Saharan Africa (all income levels) in 2002 to that in 2005?
Provide a succinct answer. 0.93. What is the ratio of the Primary completion rate (% of total enrollments) in Colombia in 2002 to that in 2005?
Your answer should be compact. 0.89. What is the ratio of the Primary completion rate (% of total enrollments) in Kuwait in 2002 to that in 2005?
Provide a short and direct response. 0.89. What is the ratio of the Primary completion rate (% of total enrollments) of Malaysia in 2002 to that in 2005?
Your answer should be very brief. 0.9. What is the ratio of the Primary completion rate (% of total enrollments) of Sub-Saharan Africa (all income levels) in 2004 to that in 2005?
Ensure brevity in your answer.  0.97. What is the ratio of the Primary completion rate (% of total enrollments) in Colombia in 2004 to that in 2005?
Provide a succinct answer. 0.96. What is the ratio of the Primary completion rate (% of total enrollments) in Kuwait in 2004 to that in 2005?
Your answer should be compact. 0.9. What is the ratio of the Primary completion rate (% of total enrollments) in Malaysia in 2004 to that in 2005?
Your response must be concise. 0.96. What is the difference between the highest and the second highest Primary completion rate (% of total enrollments) in Sub-Saharan Africa (all income levels)?
Your response must be concise. 2.2. What is the difference between the highest and the second highest Primary completion rate (% of total enrollments) in Colombia?
Your response must be concise. 3.7. What is the difference between the highest and the second highest Primary completion rate (% of total enrollments) of Kuwait?
Give a very brief answer. 7.34. What is the difference between the highest and the second highest Primary completion rate (% of total enrollments) in Malaysia?
Provide a succinct answer. 4.3. What is the difference between the highest and the lowest Primary completion rate (% of total enrollments) of Sub-Saharan Africa (all income levels)?
Offer a very short reply. 8.88. What is the difference between the highest and the lowest Primary completion rate (% of total enrollments) in Colombia?
Keep it short and to the point. 36.96. What is the difference between the highest and the lowest Primary completion rate (% of total enrollments) of Kuwait?
Provide a succinct answer. 29.73. What is the difference between the highest and the lowest Primary completion rate (% of total enrollments) in Malaysia?
Provide a succinct answer. 10.55. 